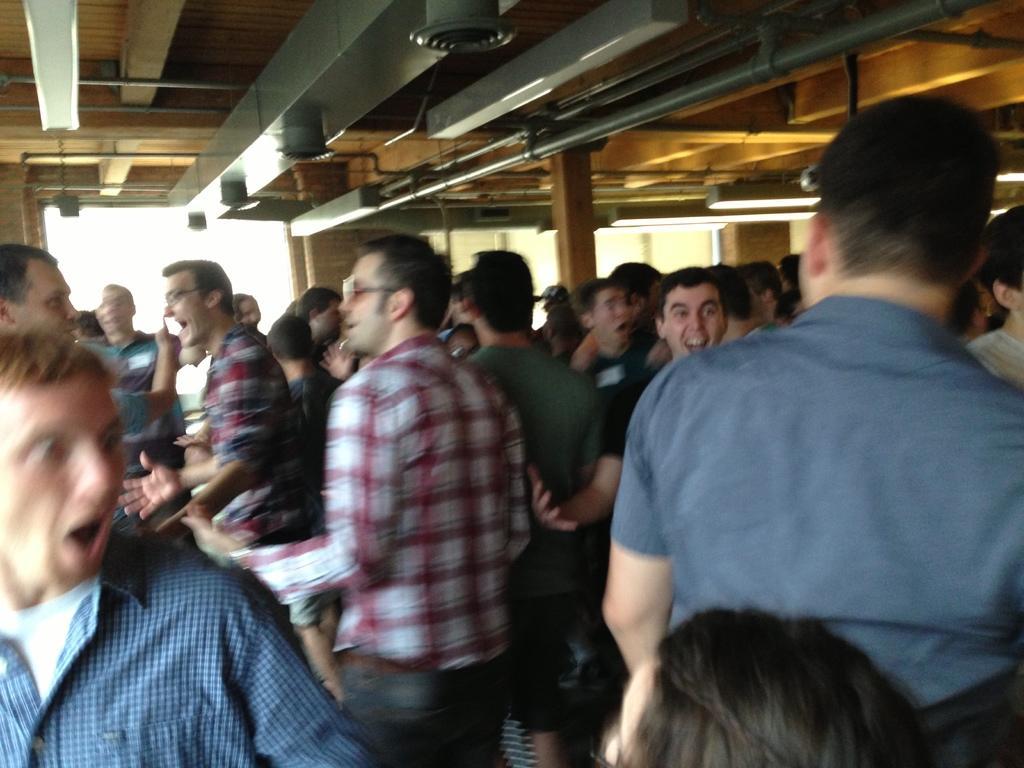Describe this image in one or two sentences. In this picture, we see the group of people are standing. The man in the middle of the picture who is wearing the red and white check shirt is wearing the spectacles. Most of them are opening their mouths. They are laughing. Behind them, we see the wooden pillars. In the background, we see the wall and a window. At the top, we see the roof of the building. 